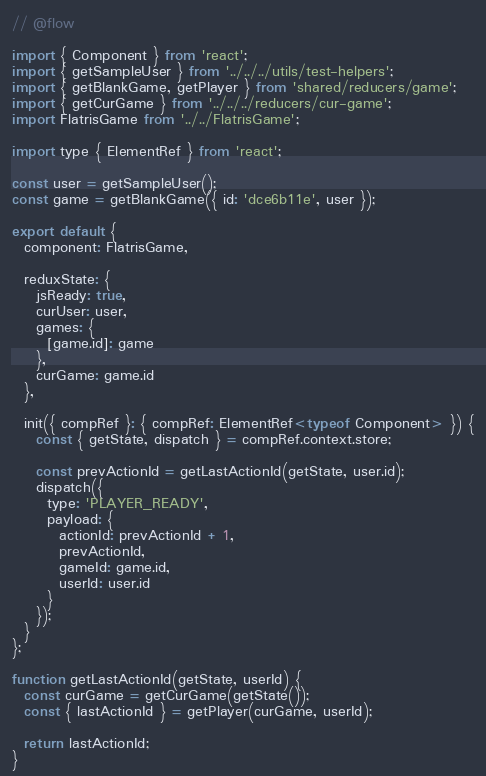Convert code to text. <code><loc_0><loc_0><loc_500><loc_500><_JavaScript_>// @flow

import { Component } from 'react';
import { getSampleUser } from '../../../utils/test-helpers';
import { getBlankGame, getPlayer } from 'shared/reducers/game';
import { getCurGame } from '../../../reducers/cur-game';
import FlatrisGame from '../../FlatrisGame';

import type { ElementRef } from 'react';

const user = getSampleUser();
const game = getBlankGame({ id: 'dce6b11e', user });

export default {
  component: FlatrisGame,

  reduxState: {
    jsReady: true,
    curUser: user,
    games: {
      [game.id]: game
    },
    curGame: game.id
  },

  init({ compRef }: { compRef: ElementRef<typeof Component> }) {
    const { getState, dispatch } = compRef.context.store;

    const prevActionId = getLastActionId(getState, user.id);
    dispatch({
      type: 'PLAYER_READY',
      payload: {
        actionId: prevActionId + 1,
        prevActionId,
        gameId: game.id,
        userId: user.id
      }
    });
  }
};

function getLastActionId(getState, userId) {
  const curGame = getCurGame(getState());
  const { lastActionId } = getPlayer(curGame, userId);

  return lastActionId;
}
</code> 